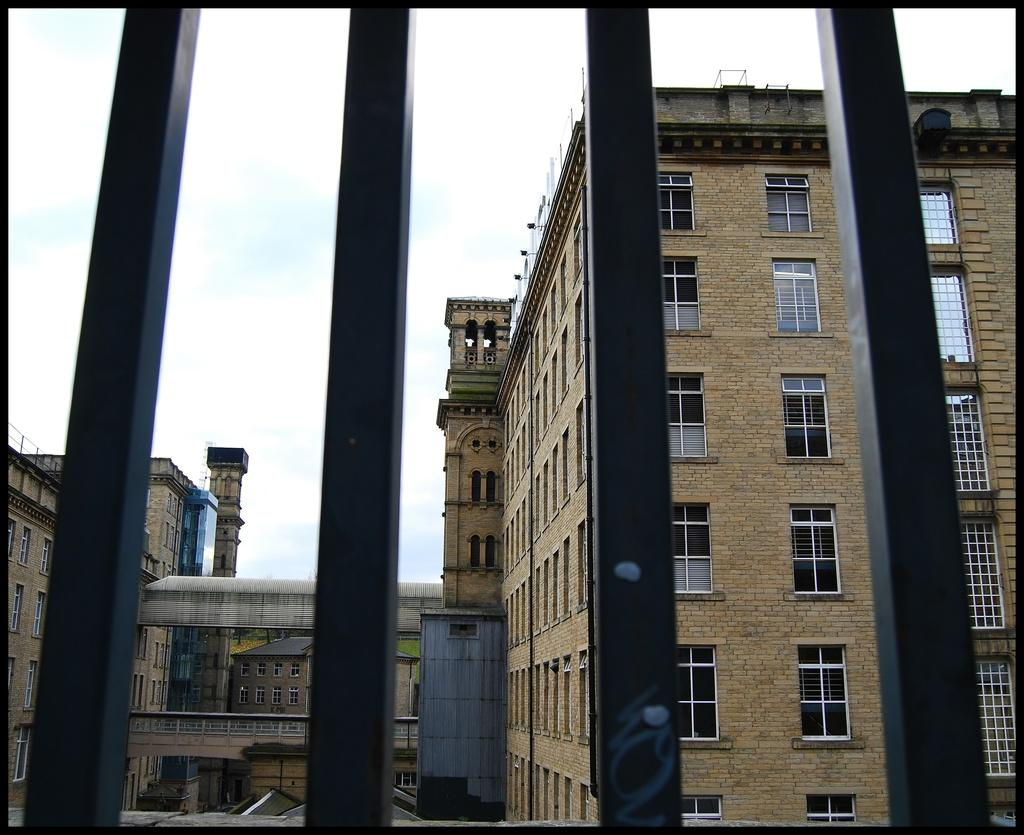What is located in the foreground of the image? There is a railing in the foreground of the image. What can be seen in the background of the image? There are many buildings in the background of the image. What is visible at the top of the image? The sky is visible at the top of the image. What time of day does the image depict, specifically in the afternoon? The provided facts do not mention the time of day, so it cannot be determined if the image depicts the afternoon. What type of tree can be seen in the image? There is no tree present in the image. 